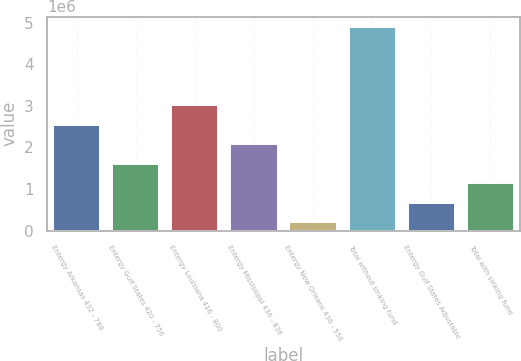Convert chart. <chart><loc_0><loc_0><loc_500><loc_500><bar_chart><fcel>Entergy Arkansas 432 - 788<fcel>Entergy Gulf States 420 - 756<fcel>Entergy Louisiana 416 - 800<fcel>Entergy Mississippi 436 - 836<fcel>Entergy New Orleans 436 - 556<fcel>Total without sinking fund<fcel>Entergy Gulf States Adjustable<fcel>Total with sinking fund<nl><fcel>2.55059e+06<fcel>1.60947e+06<fcel>3.02114e+06<fcel>2.08003e+06<fcel>197798<fcel>4.90337e+06<fcel>668356<fcel>1.13891e+06<nl></chart> 